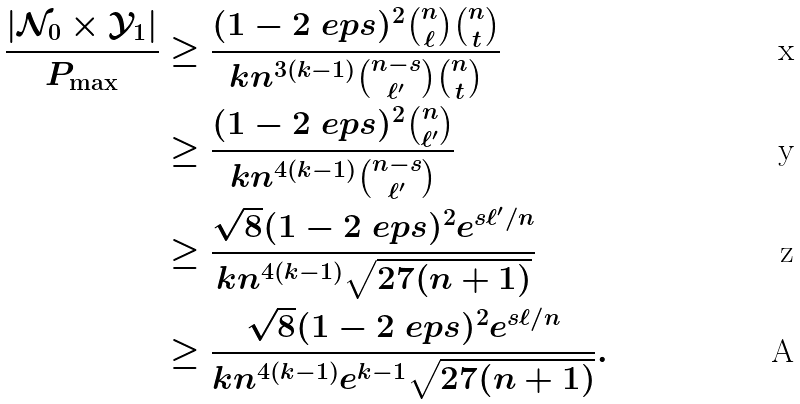Convert formula to latex. <formula><loc_0><loc_0><loc_500><loc_500>\frac { | \mathcal { N } _ { 0 } \times \mathcal { Y } _ { 1 } | } { P _ { \max } } & \geq \frac { ( 1 - 2 \ e p s ) ^ { 2 } \binom { n } { \ell } \binom { n } { t } } { k n ^ { 3 ( k - 1 ) } \binom { n - s } { \ell ^ { \prime } } \binom { n } { t } } \\ & \geq \frac { ( 1 - 2 \ e p s ) ^ { 2 } \binom { n } { \ell ^ { \prime } } } { k n ^ { 4 ( k - 1 ) } \binom { n - s } { \ell ^ { \prime } } } \\ & \geq \frac { \sqrt { 8 } ( 1 - 2 \ e p s ) ^ { 2 } e ^ { s \ell ^ { \prime } / n } } { k n ^ { 4 ( k - 1 ) } \sqrt { 2 7 ( n + 1 ) } } \\ & \geq \frac { \sqrt { 8 } ( 1 - 2 \ e p s ) ^ { 2 } e ^ { s \ell / n } } { k n ^ { 4 ( k - 1 ) } e ^ { k - 1 } \sqrt { 2 7 ( n + 1 ) } } .</formula> 